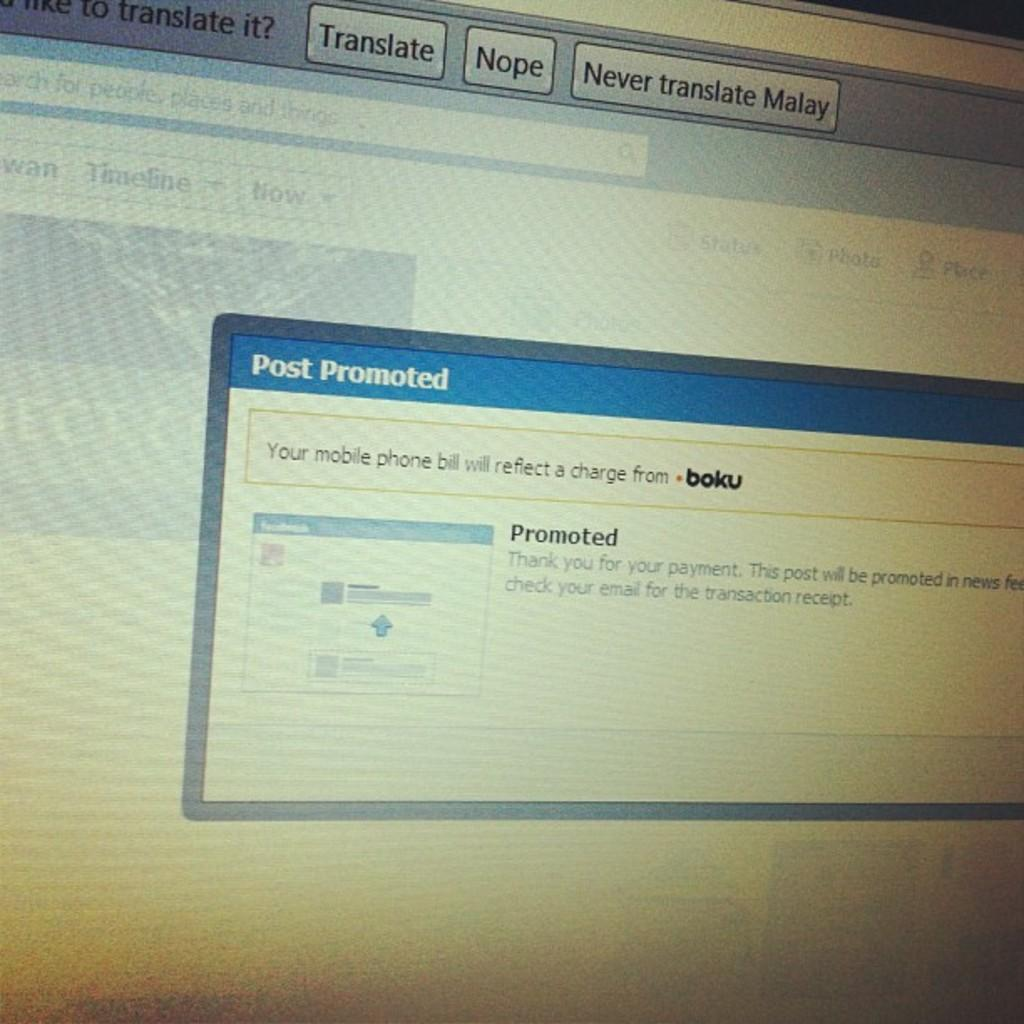<image>
Relay a brief, clear account of the picture shown. A facebook post about a post promoted and the mobile phone bill. 